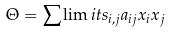Convert formula to latex. <formula><loc_0><loc_0><loc_500><loc_500>\Theta = \sum \lim i t s _ { i , j } a _ { i j } x _ { i } x _ { j }</formula> 